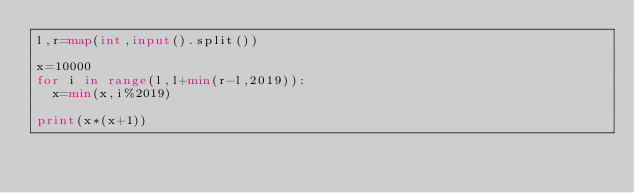<code> <loc_0><loc_0><loc_500><loc_500><_Python_>l,r=map(int,input().split())

x=10000
for i in range(l,l+min(r-l,2019)):
  x=min(x,i%2019)

print(x*(x+1))</code> 